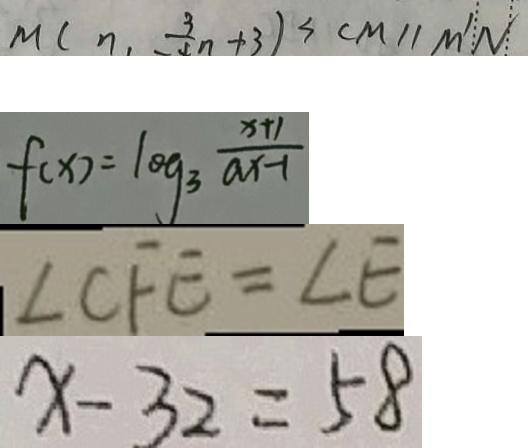Convert formula to latex. <formula><loc_0><loc_0><loc_500><loc_500>M ( n , - \frac { 3 } { 4 } n + 3 ) = ( C M \vert \vert M ^ { \prime } N ) 
 f ( x ) = \log _ { 3 } \frac { x + 1 } { a x - 1 } 
 \angle C F E = \angle E 
 x - 3 2 = 5 8</formula> 